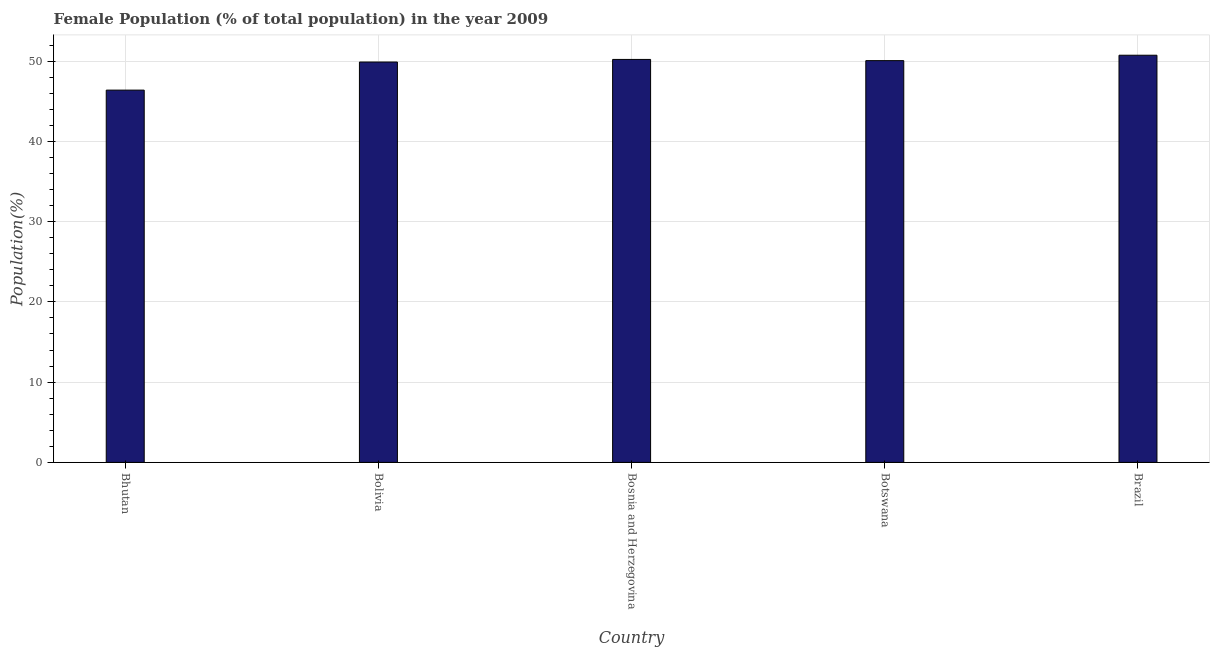Does the graph contain any zero values?
Ensure brevity in your answer.  No. What is the title of the graph?
Offer a very short reply. Female Population (% of total population) in the year 2009. What is the label or title of the Y-axis?
Your answer should be compact. Population(%). What is the female population in Bhutan?
Give a very brief answer. 46.38. Across all countries, what is the maximum female population?
Your answer should be very brief. 50.73. Across all countries, what is the minimum female population?
Your answer should be very brief. 46.38. In which country was the female population maximum?
Offer a terse response. Brazil. In which country was the female population minimum?
Offer a terse response. Bhutan. What is the sum of the female population?
Ensure brevity in your answer.  247.24. What is the difference between the female population in Bosnia and Herzegovina and Brazil?
Offer a terse response. -0.52. What is the average female population per country?
Offer a terse response. 49.45. What is the median female population?
Ensure brevity in your answer.  50.05. In how many countries, is the female population greater than 16 %?
Provide a short and direct response. 5. Is the female population in Botswana less than that in Brazil?
Give a very brief answer. Yes. Is the difference between the female population in Bolivia and Brazil greater than the difference between any two countries?
Keep it short and to the point. No. What is the difference between the highest and the second highest female population?
Your answer should be very brief. 0.52. What is the difference between the highest and the lowest female population?
Make the answer very short. 4.35. How many bars are there?
Give a very brief answer. 5. What is the Population(%) in Bhutan?
Your answer should be compact. 46.38. What is the Population(%) of Bolivia?
Give a very brief answer. 49.88. What is the Population(%) of Bosnia and Herzegovina?
Provide a succinct answer. 50.2. What is the Population(%) in Botswana?
Make the answer very short. 50.05. What is the Population(%) in Brazil?
Keep it short and to the point. 50.73. What is the difference between the Population(%) in Bhutan and Bolivia?
Provide a short and direct response. -3.5. What is the difference between the Population(%) in Bhutan and Bosnia and Herzegovina?
Your answer should be very brief. -3.82. What is the difference between the Population(%) in Bhutan and Botswana?
Make the answer very short. -3.67. What is the difference between the Population(%) in Bhutan and Brazil?
Your answer should be very brief. -4.35. What is the difference between the Population(%) in Bolivia and Bosnia and Herzegovina?
Offer a very short reply. -0.32. What is the difference between the Population(%) in Bolivia and Botswana?
Offer a terse response. -0.17. What is the difference between the Population(%) in Bolivia and Brazil?
Give a very brief answer. -0.85. What is the difference between the Population(%) in Bosnia and Herzegovina and Botswana?
Make the answer very short. 0.15. What is the difference between the Population(%) in Bosnia and Herzegovina and Brazil?
Your answer should be compact. -0.52. What is the difference between the Population(%) in Botswana and Brazil?
Provide a succinct answer. -0.67. What is the ratio of the Population(%) in Bhutan to that in Bolivia?
Give a very brief answer. 0.93. What is the ratio of the Population(%) in Bhutan to that in Bosnia and Herzegovina?
Your answer should be compact. 0.92. What is the ratio of the Population(%) in Bhutan to that in Botswana?
Provide a succinct answer. 0.93. What is the ratio of the Population(%) in Bhutan to that in Brazil?
Provide a succinct answer. 0.91. What is the ratio of the Population(%) in Bosnia and Herzegovina to that in Botswana?
Provide a short and direct response. 1. What is the ratio of the Population(%) in Botswana to that in Brazil?
Give a very brief answer. 0.99. 